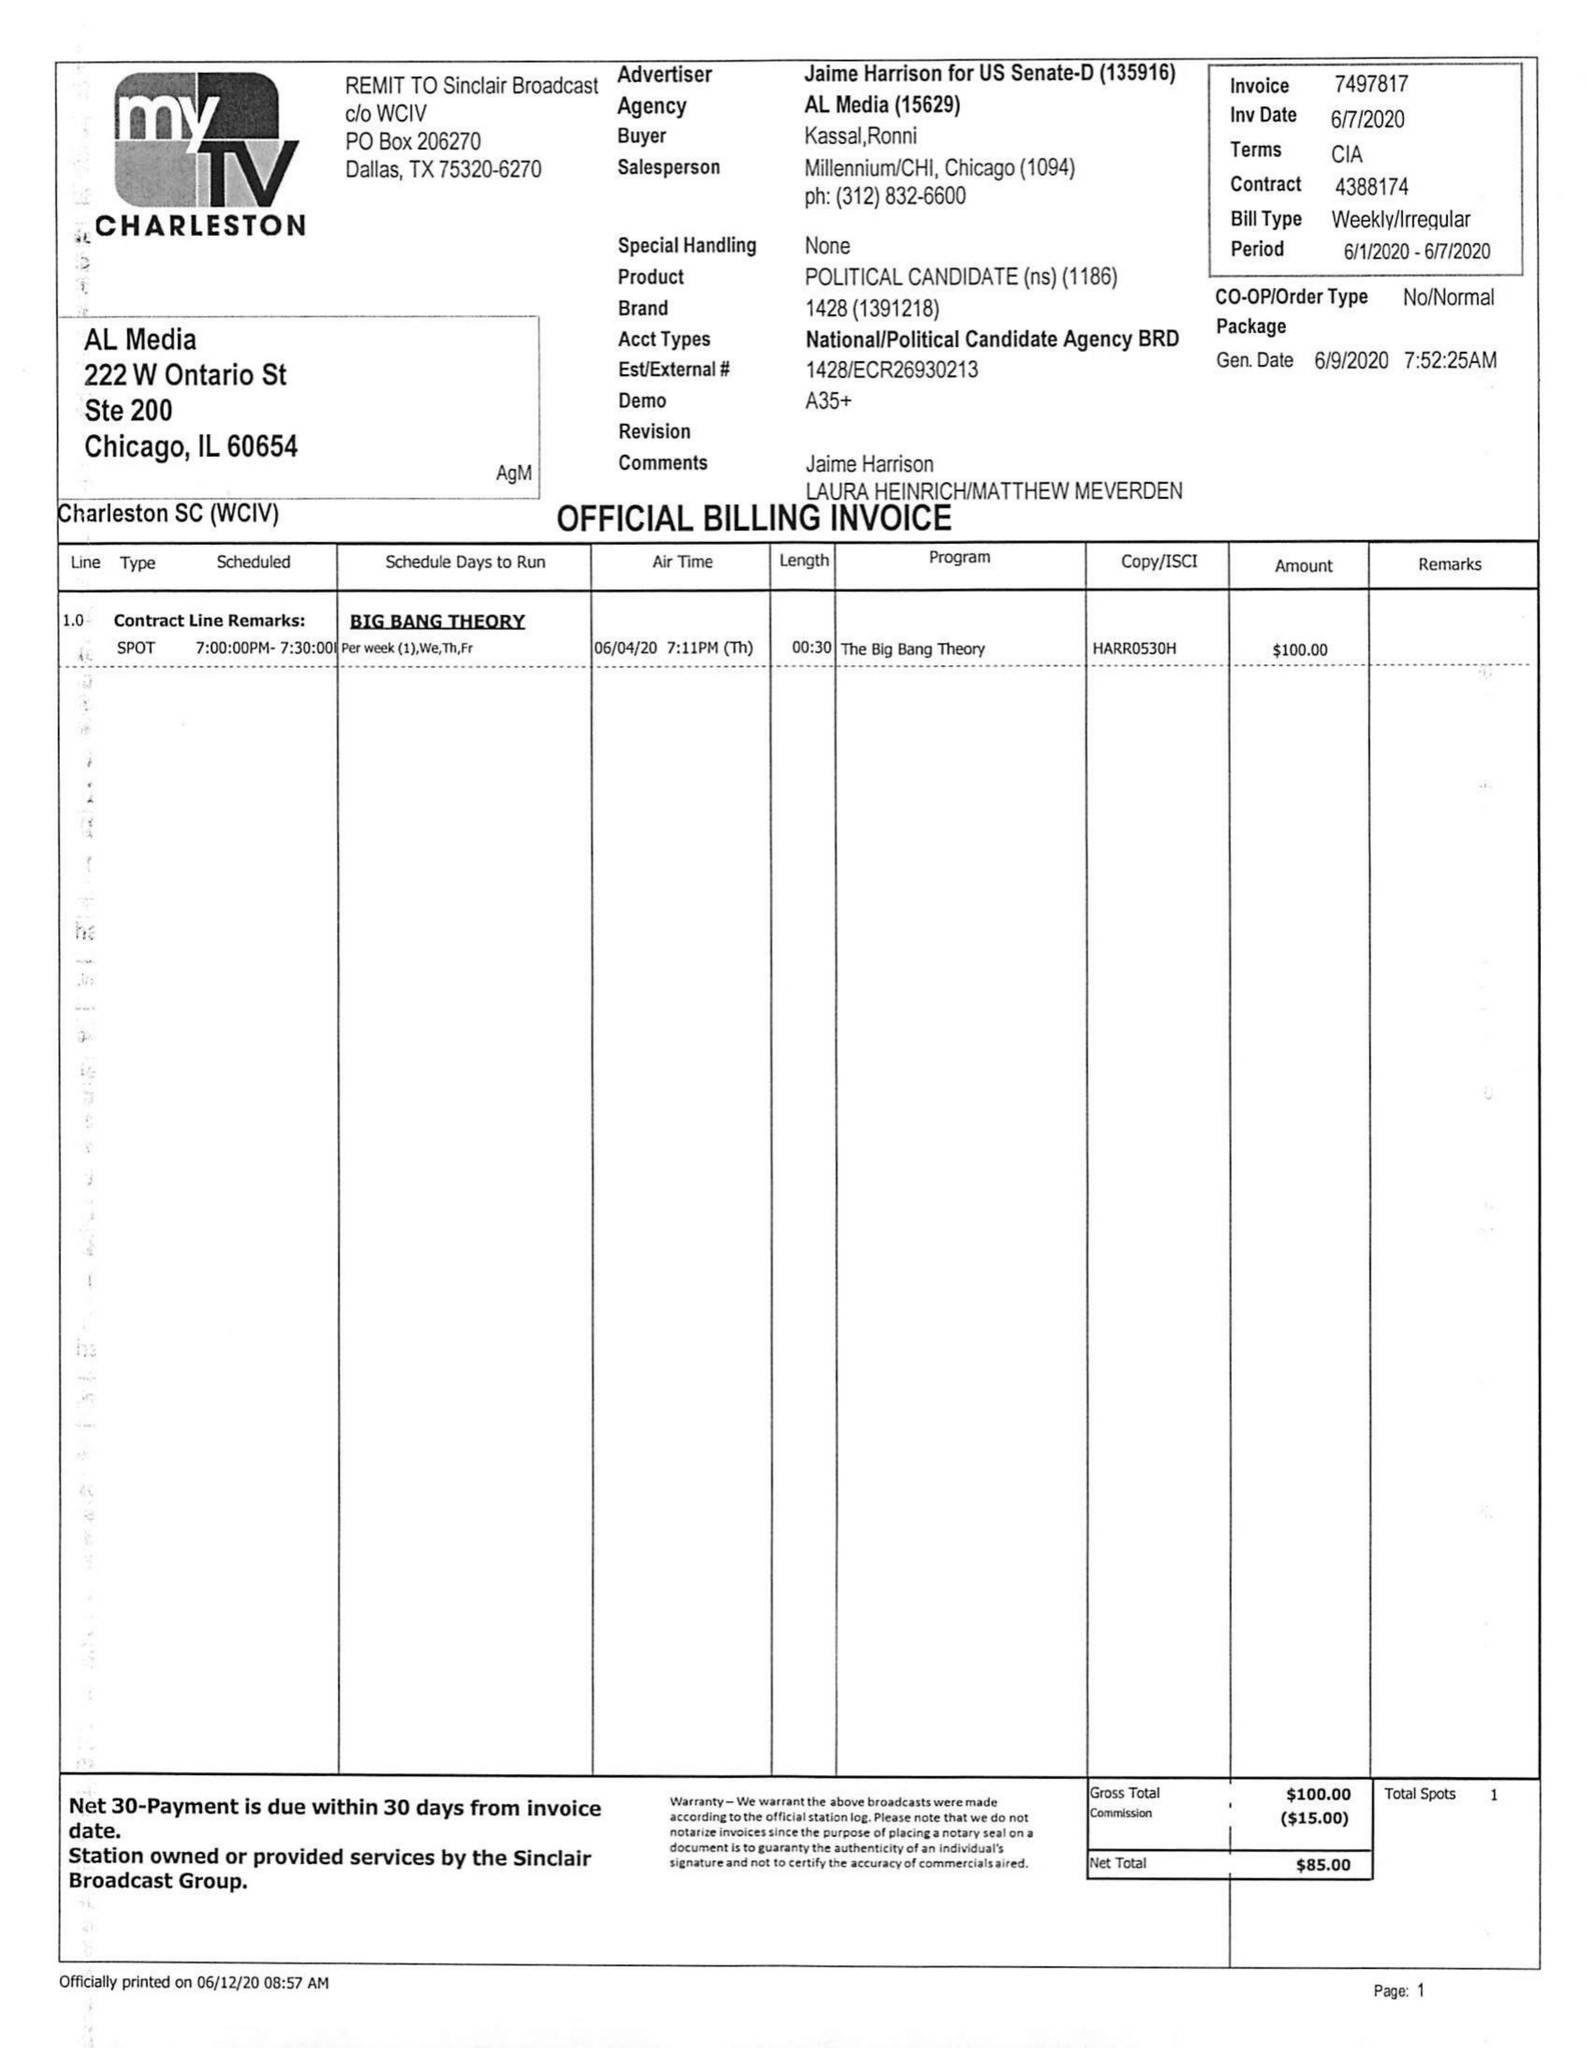What is the value for the gross_amount?
Answer the question using a single word or phrase. 100.00 